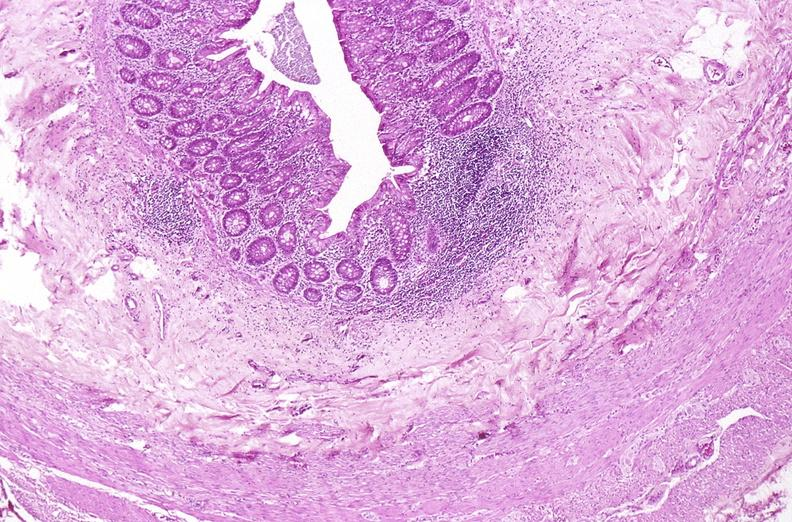s gastrointestinal present?
Answer the question using a single word or phrase. Yes 